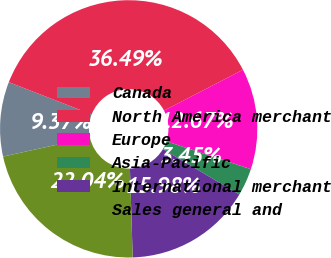Convert chart to OTSL. <chart><loc_0><loc_0><loc_500><loc_500><pie_chart><fcel>Canada<fcel>North America merchant<fcel>Europe<fcel>Asia-Pacific<fcel>International merchant<fcel>Sales general and<nl><fcel>9.37%<fcel>36.49%<fcel>12.67%<fcel>3.45%<fcel>15.98%<fcel>22.04%<nl></chart> 